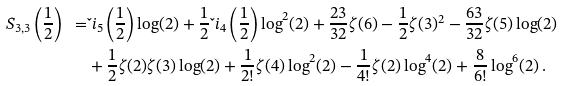Convert formula to latex. <formula><loc_0><loc_0><loc_500><loc_500>S _ { 3 , 3 } \left ( \frac { 1 } { 2 } \right ) \ = & \L i _ { 5 } \left ( \frac { 1 } { 2 } \right ) \log ( 2 ) + \frac { 1 } { 2 } \L i _ { 4 } \left ( \frac { 1 } { 2 } \right ) \log ^ { 2 } ( 2 ) + \frac { 2 3 } { 3 2 } \zeta ( 6 ) - \frac { 1 } { 2 } \zeta ( 3 ) ^ { 2 } - \frac { 6 3 } { 3 2 } \zeta ( 5 ) \log ( 2 ) \\ & + \frac { 1 } { 2 } \zeta ( 2 ) \zeta ( 3 ) \log ( 2 ) + \frac { 1 } { 2 ! } \zeta ( 4 ) \log ^ { 2 } ( 2 ) - \frac { 1 } { 4 ! } \zeta ( 2 ) \log ^ { 4 } ( 2 ) + \frac { 8 } { 6 ! } \log ^ { 6 } ( 2 ) \, .</formula> 